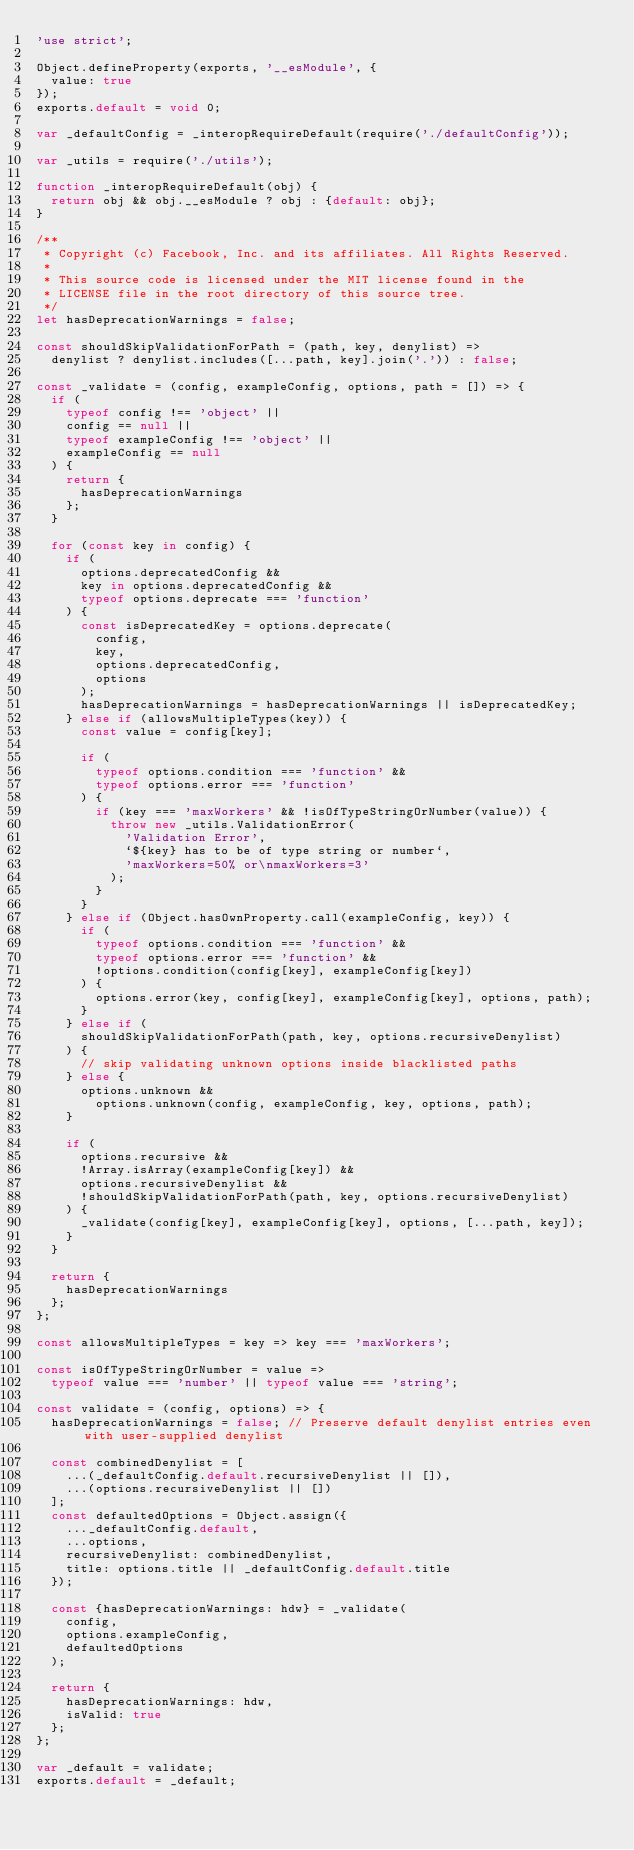Convert code to text. <code><loc_0><loc_0><loc_500><loc_500><_JavaScript_>'use strict';

Object.defineProperty(exports, '__esModule', {
  value: true
});
exports.default = void 0;

var _defaultConfig = _interopRequireDefault(require('./defaultConfig'));

var _utils = require('./utils');

function _interopRequireDefault(obj) {
  return obj && obj.__esModule ? obj : {default: obj};
}

/**
 * Copyright (c) Facebook, Inc. and its affiliates. All Rights Reserved.
 *
 * This source code is licensed under the MIT license found in the
 * LICENSE file in the root directory of this source tree.
 */
let hasDeprecationWarnings = false;

const shouldSkipValidationForPath = (path, key, denylist) =>
  denylist ? denylist.includes([...path, key].join('.')) : false;

const _validate = (config, exampleConfig, options, path = []) => {
  if (
    typeof config !== 'object' ||
    config == null ||
    typeof exampleConfig !== 'object' ||
    exampleConfig == null
  ) {
    return {
      hasDeprecationWarnings
    };
  }

  for (const key in config) {
    if (
      options.deprecatedConfig &&
      key in options.deprecatedConfig &&
      typeof options.deprecate === 'function'
    ) {
      const isDeprecatedKey = options.deprecate(
        config,
        key,
        options.deprecatedConfig,
        options
      );
      hasDeprecationWarnings = hasDeprecationWarnings || isDeprecatedKey;
    } else if (allowsMultipleTypes(key)) {
      const value = config[key];

      if (
        typeof options.condition === 'function' &&
        typeof options.error === 'function'
      ) {
        if (key === 'maxWorkers' && !isOfTypeStringOrNumber(value)) {
          throw new _utils.ValidationError(
            'Validation Error',
            `${key} has to be of type string or number`,
            'maxWorkers=50% or\nmaxWorkers=3'
          );
        }
      }
    } else if (Object.hasOwnProperty.call(exampleConfig, key)) {
      if (
        typeof options.condition === 'function' &&
        typeof options.error === 'function' &&
        !options.condition(config[key], exampleConfig[key])
      ) {
        options.error(key, config[key], exampleConfig[key], options, path);
      }
    } else if (
      shouldSkipValidationForPath(path, key, options.recursiveDenylist)
    ) {
      // skip validating unknown options inside blacklisted paths
    } else {
      options.unknown &&
        options.unknown(config, exampleConfig, key, options, path);
    }

    if (
      options.recursive &&
      !Array.isArray(exampleConfig[key]) &&
      options.recursiveDenylist &&
      !shouldSkipValidationForPath(path, key, options.recursiveDenylist)
    ) {
      _validate(config[key], exampleConfig[key], options, [...path, key]);
    }
  }

  return {
    hasDeprecationWarnings
  };
};

const allowsMultipleTypes = key => key === 'maxWorkers';

const isOfTypeStringOrNumber = value =>
  typeof value === 'number' || typeof value === 'string';

const validate = (config, options) => {
  hasDeprecationWarnings = false; // Preserve default denylist entries even with user-supplied denylist

  const combinedDenylist = [
    ...(_defaultConfig.default.recursiveDenylist || []),
    ...(options.recursiveDenylist || [])
  ];
  const defaultedOptions = Object.assign({
    ..._defaultConfig.default,
    ...options,
    recursiveDenylist: combinedDenylist,
    title: options.title || _defaultConfig.default.title
  });

  const {hasDeprecationWarnings: hdw} = _validate(
    config,
    options.exampleConfig,
    defaultedOptions
  );

  return {
    hasDeprecationWarnings: hdw,
    isValid: true
  };
};

var _default = validate;
exports.default = _default;
</code> 